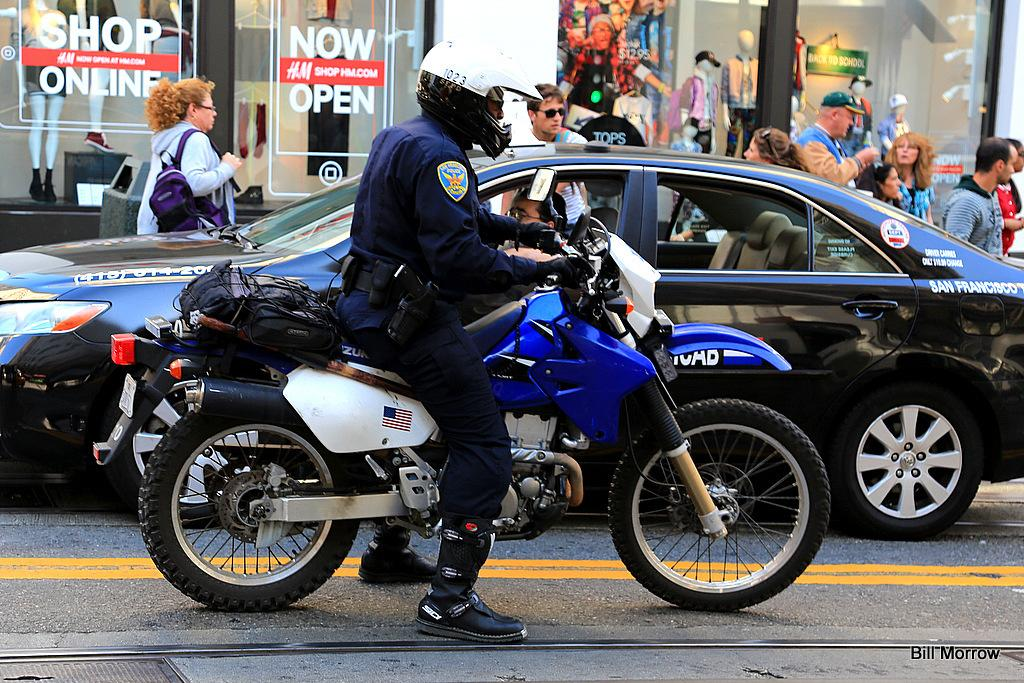What is the person in the image doing? The person is sitting on a bike in the image. What else can be seen on the road in the image? There is a car parked on the road in the image. How is the car positioned in relation to the person on the bike? The car is beside the person on the bike. Are there any other people visible in the image? Yes, there are people standing on the road in the image. What type of cake is being served to the dinosaurs in the image? There are no dinosaurs or cake present in the image. 